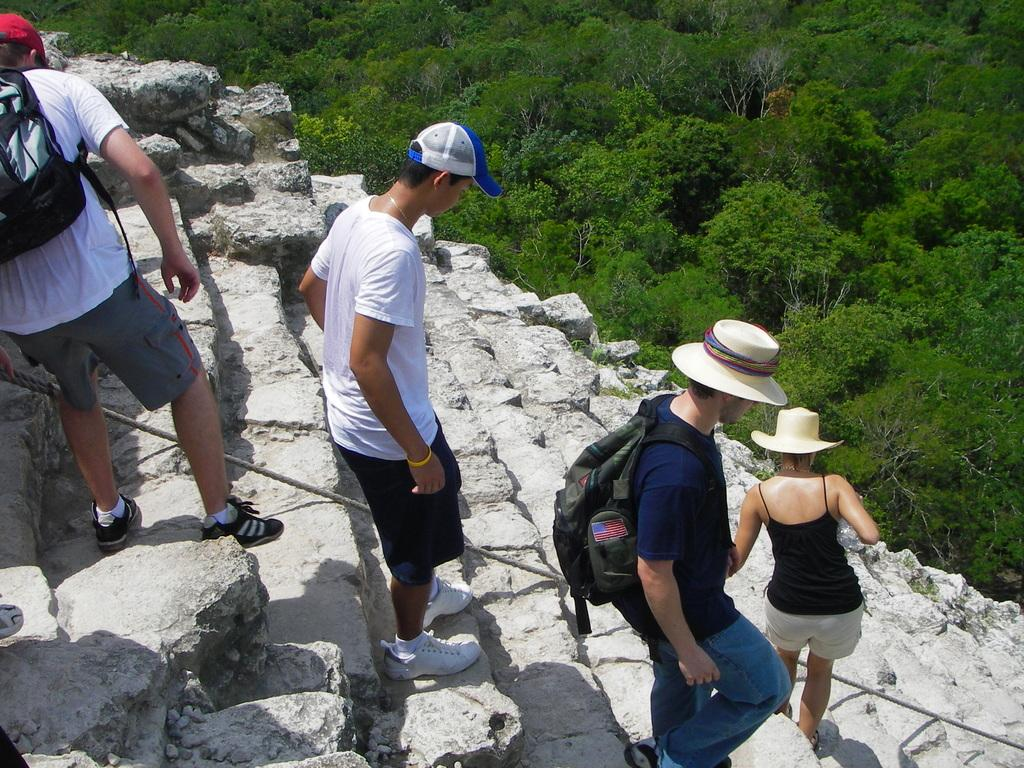How many people are in the image? There are four persons in the image. Where are the persons located in the image? The persons are on the stairs. What are two of the persons carrying? Two of the persons are wearing bags. What can be seen in the background of the image? There are trees visible in the image. What type of jelly is being used to hold the stairs together in the image? There is no jelly present in the image, and it is not being used to hold the stairs together. Can you tell me the name of the mom in the image? There is no indication of a mom or any specific person's name in the image. 